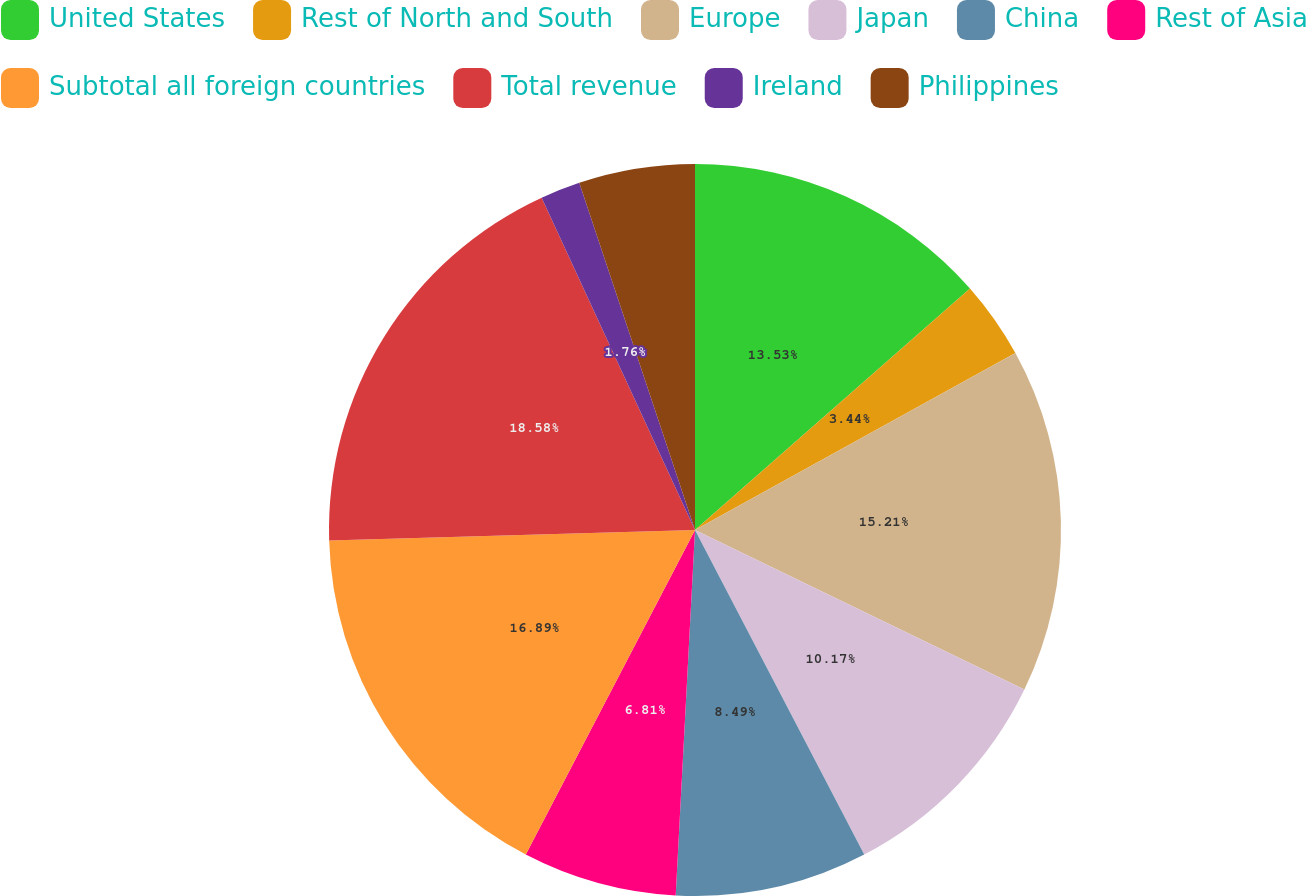<chart> <loc_0><loc_0><loc_500><loc_500><pie_chart><fcel>United States<fcel>Rest of North and South<fcel>Europe<fcel>Japan<fcel>China<fcel>Rest of Asia<fcel>Subtotal all foreign countries<fcel>Total revenue<fcel>Ireland<fcel>Philippines<nl><fcel>13.53%<fcel>3.44%<fcel>15.21%<fcel>10.17%<fcel>8.49%<fcel>6.81%<fcel>16.89%<fcel>18.58%<fcel>1.76%<fcel>5.12%<nl></chart> 